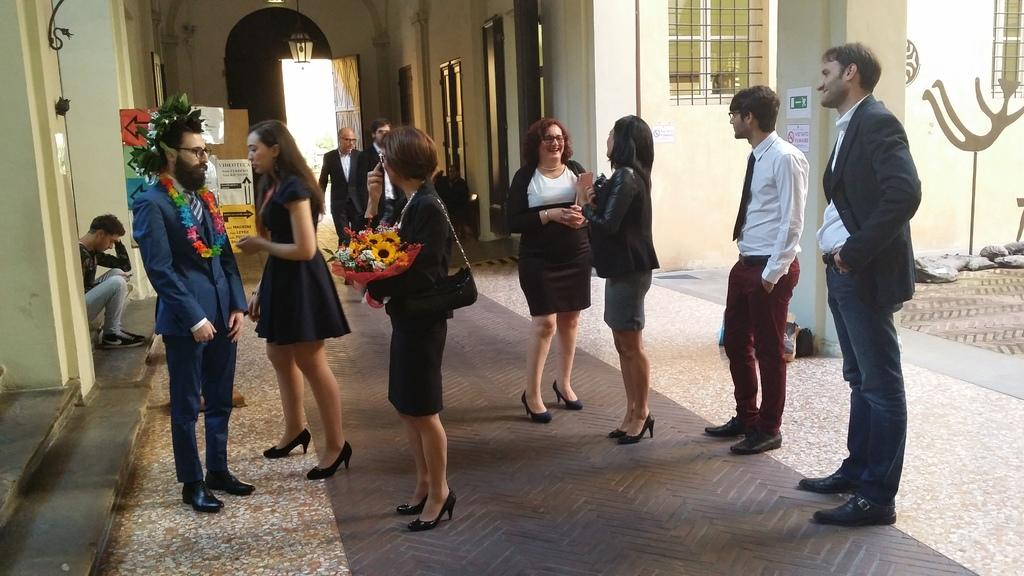What can be seen in the image involving people? There are people standing in the image. What type of structure is present in the image? There is a wall in the image. What architectural features are visible in the wall? There are windows and a door in the image. What type of prison is depicted in the image? There is no prison present in the image; it features people standing near a wall with windows and a door. What committee is meeting in the image? There is no committee meeting in the image; it simply shows people standing near a wall with windows and a door. 